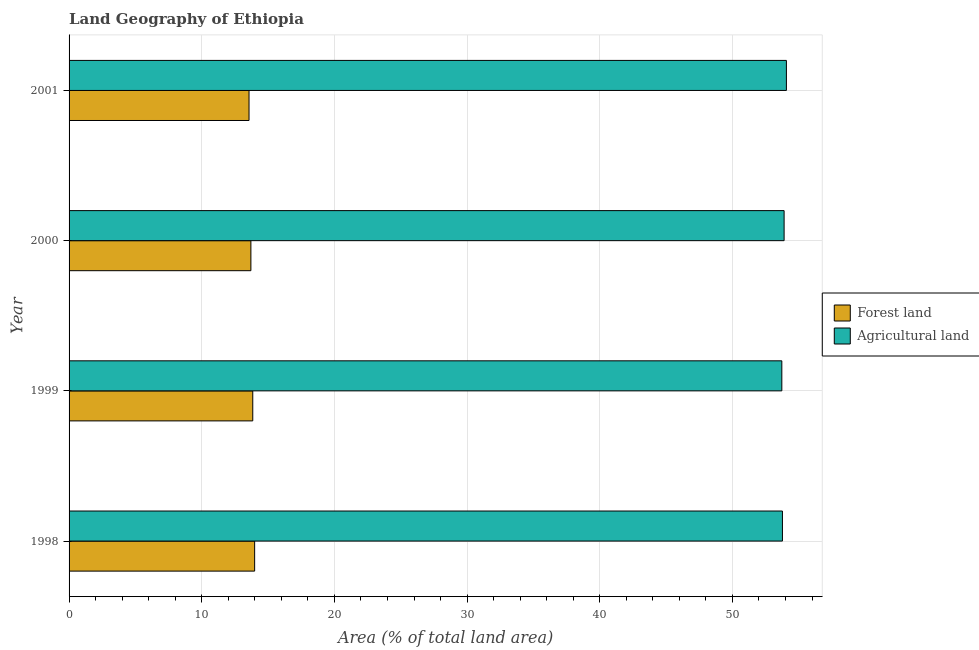How many groups of bars are there?
Offer a very short reply. 4. Are the number of bars per tick equal to the number of legend labels?
Your response must be concise. Yes. What is the label of the 2nd group of bars from the top?
Offer a very short reply. 2000. In how many cases, is the number of bars for a given year not equal to the number of legend labels?
Offer a terse response. 0. What is the percentage of land area under forests in 2001?
Offer a terse response. 13.56. Across all years, what is the maximum percentage of land area under agriculture?
Provide a short and direct response. 54.07. Across all years, what is the minimum percentage of land area under forests?
Your answer should be compact. 13.56. In which year was the percentage of land area under forests maximum?
Your answer should be compact. 1998. What is the total percentage of land area under agriculture in the graph?
Keep it short and to the point. 215.46. What is the difference between the percentage of land area under forests in 1998 and that in 1999?
Make the answer very short. 0.14. What is the difference between the percentage of land area under forests in 1999 and the percentage of land area under agriculture in 2001?
Your answer should be compact. -40.22. What is the average percentage of land area under agriculture per year?
Make the answer very short. 53.87. In the year 1998, what is the difference between the percentage of land area under forests and percentage of land area under agriculture?
Offer a terse response. -39.78. In how many years, is the percentage of land area under forests greater than 38 %?
Offer a terse response. 0. Is the percentage of land area under forests in 1999 less than that in 2001?
Provide a short and direct response. No. Is the difference between the percentage of land area under agriculture in 1998 and 2000 greater than the difference between the percentage of land area under forests in 1998 and 2000?
Ensure brevity in your answer.  No. What is the difference between the highest and the second highest percentage of land area under agriculture?
Offer a very short reply. 0.17. What is the difference between the highest and the lowest percentage of land area under agriculture?
Your answer should be very brief. 0.35. Is the sum of the percentage of land area under forests in 2000 and 2001 greater than the maximum percentage of land area under agriculture across all years?
Provide a short and direct response. No. What does the 2nd bar from the top in 2001 represents?
Offer a terse response. Forest land. What does the 1st bar from the bottom in 2000 represents?
Provide a short and direct response. Forest land. How many bars are there?
Give a very brief answer. 8. What is the difference between two consecutive major ticks on the X-axis?
Make the answer very short. 10. Are the values on the major ticks of X-axis written in scientific E-notation?
Make the answer very short. No. Does the graph contain any zero values?
Offer a very short reply. No. Does the graph contain grids?
Make the answer very short. Yes. Where does the legend appear in the graph?
Provide a succinct answer. Center right. How many legend labels are there?
Make the answer very short. 2. How are the legend labels stacked?
Your answer should be compact. Vertical. What is the title of the graph?
Your answer should be very brief. Land Geography of Ethiopia. What is the label or title of the X-axis?
Give a very brief answer. Area (% of total land area). What is the label or title of the Y-axis?
Offer a terse response. Year. What is the Area (% of total land area) in Forest land in 1998?
Your answer should be very brief. 13.99. What is the Area (% of total land area) of Agricultural land in 1998?
Give a very brief answer. 53.77. What is the Area (% of total land area) in Forest land in 1999?
Provide a short and direct response. 13.85. What is the Area (% of total land area) in Agricultural land in 1999?
Provide a short and direct response. 53.72. What is the Area (% of total land area) in Forest land in 2000?
Make the answer very short. 13.71. What is the Area (% of total land area) of Agricultural land in 2000?
Offer a very short reply. 53.9. What is the Area (% of total land area) in Forest land in 2001?
Your answer should be very brief. 13.56. What is the Area (% of total land area) in Agricultural land in 2001?
Offer a terse response. 54.07. Across all years, what is the maximum Area (% of total land area) of Forest land?
Provide a short and direct response. 13.99. Across all years, what is the maximum Area (% of total land area) in Agricultural land?
Provide a succinct answer. 54.07. Across all years, what is the minimum Area (% of total land area) in Forest land?
Offer a terse response. 13.56. Across all years, what is the minimum Area (% of total land area) of Agricultural land?
Your response must be concise. 53.72. What is the total Area (% of total land area) of Forest land in the graph?
Your answer should be very brief. 55.1. What is the total Area (% of total land area) of Agricultural land in the graph?
Keep it short and to the point. 215.46. What is the difference between the Area (% of total land area) in Forest land in 1998 and that in 1999?
Your answer should be compact. 0.14. What is the difference between the Area (% of total land area) of Agricultural land in 1998 and that in 1999?
Provide a succinct answer. 0.05. What is the difference between the Area (% of total land area) in Forest land in 1998 and that in 2000?
Give a very brief answer. 0.28. What is the difference between the Area (% of total land area) in Agricultural land in 1998 and that in 2000?
Your answer should be very brief. -0.13. What is the difference between the Area (% of total land area) in Forest land in 1998 and that in 2001?
Keep it short and to the point. 0.42. What is the difference between the Area (% of total land area) in Agricultural land in 1998 and that in 2001?
Make the answer very short. -0.3. What is the difference between the Area (% of total land area) of Forest land in 1999 and that in 2000?
Ensure brevity in your answer.  0.14. What is the difference between the Area (% of total land area) of Agricultural land in 1999 and that in 2000?
Ensure brevity in your answer.  -0.17. What is the difference between the Area (% of total land area) of Forest land in 1999 and that in 2001?
Ensure brevity in your answer.  0.28. What is the difference between the Area (% of total land area) of Agricultural land in 1999 and that in 2001?
Keep it short and to the point. -0.35. What is the difference between the Area (% of total land area) of Forest land in 2000 and that in 2001?
Provide a short and direct response. 0.14. What is the difference between the Area (% of total land area) of Agricultural land in 2000 and that in 2001?
Offer a terse response. -0.17. What is the difference between the Area (% of total land area) of Forest land in 1998 and the Area (% of total land area) of Agricultural land in 1999?
Provide a succinct answer. -39.74. What is the difference between the Area (% of total land area) in Forest land in 1998 and the Area (% of total land area) in Agricultural land in 2000?
Keep it short and to the point. -39.91. What is the difference between the Area (% of total land area) in Forest land in 1998 and the Area (% of total land area) in Agricultural land in 2001?
Provide a short and direct response. -40.08. What is the difference between the Area (% of total land area) in Forest land in 1999 and the Area (% of total land area) in Agricultural land in 2000?
Provide a short and direct response. -40.05. What is the difference between the Area (% of total land area) in Forest land in 1999 and the Area (% of total land area) in Agricultural land in 2001?
Offer a very short reply. -40.22. What is the difference between the Area (% of total land area) in Forest land in 2000 and the Area (% of total land area) in Agricultural land in 2001?
Your answer should be very brief. -40.36. What is the average Area (% of total land area) in Forest land per year?
Your answer should be compact. 13.78. What is the average Area (% of total land area) of Agricultural land per year?
Keep it short and to the point. 53.86. In the year 1998, what is the difference between the Area (% of total land area) in Forest land and Area (% of total land area) in Agricultural land?
Ensure brevity in your answer.  -39.78. In the year 1999, what is the difference between the Area (% of total land area) of Forest land and Area (% of total land area) of Agricultural land?
Provide a succinct answer. -39.88. In the year 2000, what is the difference between the Area (% of total land area) in Forest land and Area (% of total land area) in Agricultural land?
Ensure brevity in your answer.  -40.19. In the year 2001, what is the difference between the Area (% of total land area) of Forest land and Area (% of total land area) of Agricultural land?
Your answer should be very brief. -40.51. What is the ratio of the Area (% of total land area) of Forest land in 1998 to that in 1999?
Provide a short and direct response. 1.01. What is the ratio of the Area (% of total land area) of Forest land in 1998 to that in 2000?
Provide a succinct answer. 1.02. What is the ratio of the Area (% of total land area) in Agricultural land in 1998 to that in 2000?
Your answer should be compact. 1. What is the ratio of the Area (% of total land area) in Forest land in 1998 to that in 2001?
Keep it short and to the point. 1.03. What is the ratio of the Area (% of total land area) in Forest land in 1999 to that in 2000?
Your response must be concise. 1.01. What is the ratio of the Area (% of total land area) of Agricultural land in 1999 to that in 2000?
Offer a very short reply. 1. What is the ratio of the Area (% of total land area) of Forest land in 1999 to that in 2001?
Offer a very short reply. 1.02. What is the ratio of the Area (% of total land area) in Agricultural land in 1999 to that in 2001?
Your answer should be compact. 0.99. What is the ratio of the Area (% of total land area) in Forest land in 2000 to that in 2001?
Your answer should be compact. 1.01. What is the ratio of the Area (% of total land area) of Agricultural land in 2000 to that in 2001?
Keep it short and to the point. 1. What is the difference between the highest and the second highest Area (% of total land area) of Forest land?
Your answer should be very brief. 0.14. What is the difference between the highest and the second highest Area (% of total land area) in Agricultural land?
Your response must be concise. 0.17. What is the difference between the highest and the lowest Area (% of total land area) of Forest land?
Keep it short and to the point. 0.42. What is the difference between the highest and the lowest Area (% of total land area) in Agricultural land?
Provide a succinct answer. 0.35. 